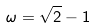Convert formula to latex. <formula><loc_0><loc_0><loc_500><loc_500>\omega = \sqrt { 2 } - 1</formula> 